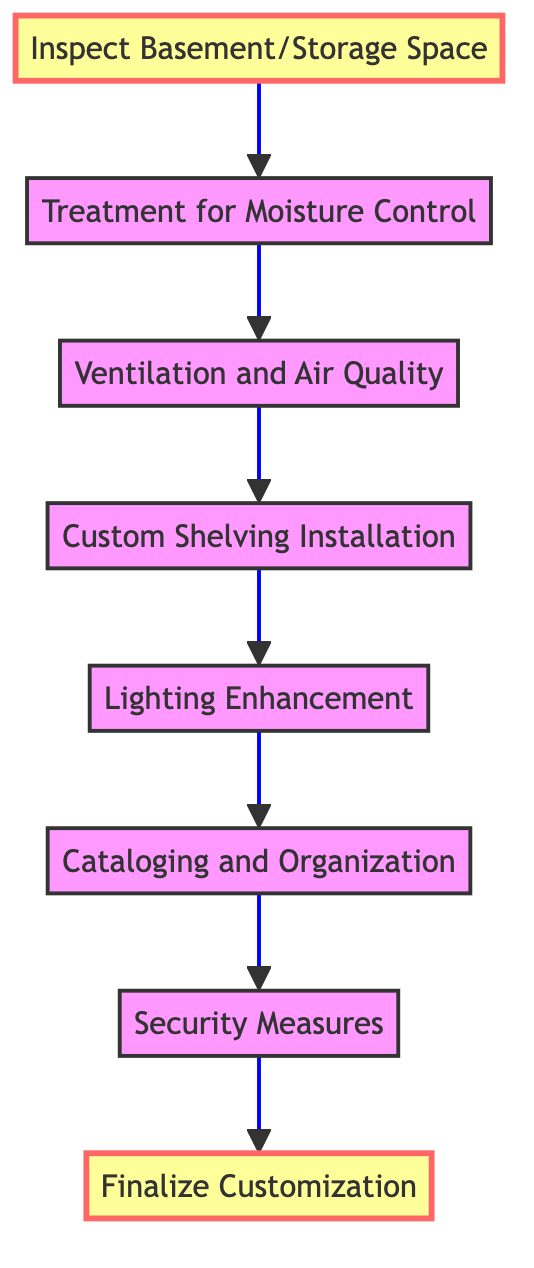What is the first step in the customization process? The first step listed in the flow chart is "Inspect Basement/Storage Space" at the bottom of the diagram.
Answer: Inspect Basement/Storage Space How many total steps are there in the process? Counting each step from the diagram, there are a total of eight steps.
Answer: 8 What is the last step of the customization process? The last step shown in the flow chart is "Finalize Customization," which is located at the top of the diagram.
Answer: Finalize Customization What is the relationship between "Ventilation and Air Quality" and "Custom Shelving Installation"? "Ventilation and Air Quality" leads directly to "Custom Shelving Installation," indicating that proper ventilation needs to be established before shelving is installed.
Answer: Directly leads to What is treated first after inspecting the basement? After inspecting the basement, the next step is "Treatment for Moisture Control," which is aimed at addressing moisture issues.
Answer: Treatment for Moisture Control Which step involves installing security systems? The step where security systems are installed is "Security Measures." This step is towards the end of the flow chart.
Answer: Security Measures How does "Lighting Enhancement" relate to its previous step? "Lighting Enhancement" follows "Custom Shelving Installation," indicating that once shelving is in place, lighting features are improved for optimal book storage.
Answer: Follows Which step comes immediately before "Cataloging and Organization"? The step that comes immediately before "Cataloging and Organization" is "Lighting Enhancement," suggesting that lighting adjustments occur before organizing the book collection.
Answer: Lighting Enhancement What is the focus of the "Cataloging and Organization" step? The focus of the "Cataloging and Organization" step is to implement systems that help organize the book collection effectively.
Answer: Organize the book collection 